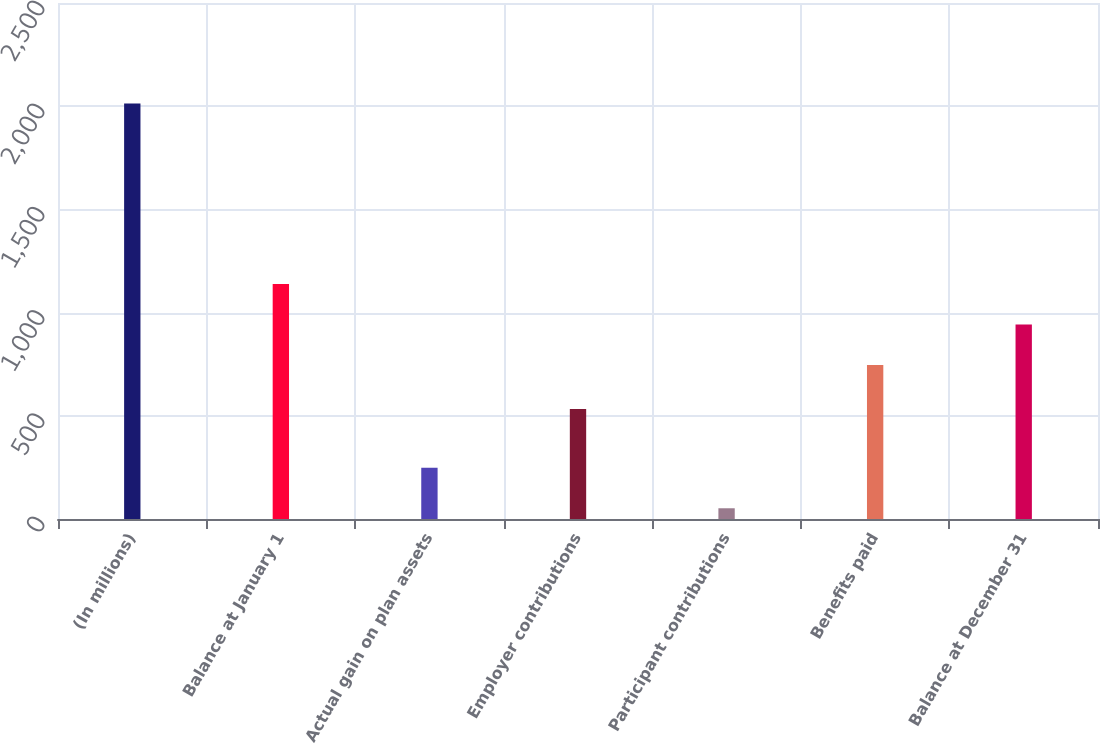<chart> <loc_0><loc_0><loc_500><loc_500><bar_chart><fcel>(In millions)<fcel>Balance at January 1<fcel>Actual gain on plan assets<fcel>Employer contributions<fcel>Participant contributions<fcel>Benefits paid<fcel>Balance at December 31<nl><fcel>2013<fcel>1138.2<fcel>248.1<fcel>533<fcel>52<fcel>746<fcel>942.1<nl></chart> 